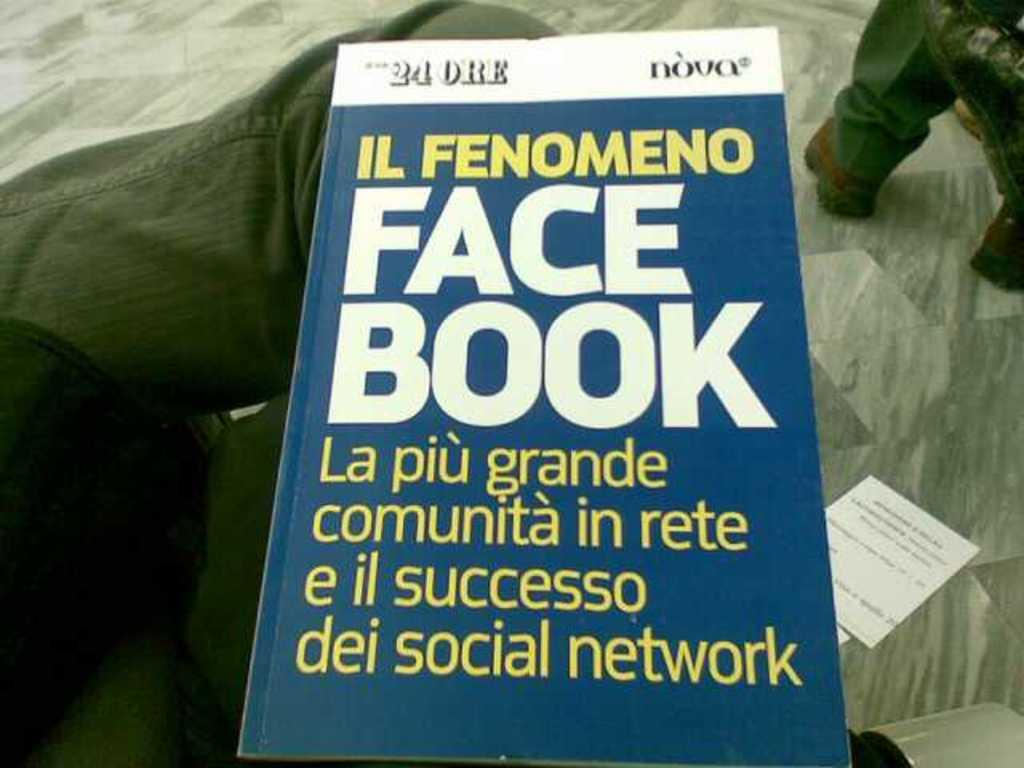What object can be seen in the image? There is a book in the image. Where is the book located? The book is on the lap of someone. What type of steel is used to make the bag in the image? There is no bag present in the image, so it is not possible to determine what type of steel might be used. 